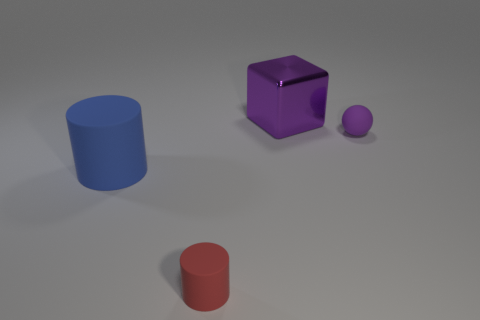Is there any other thing that has the same color as the matte sphere?
Provide a short and direct response. Yes. There is a tiny thing on the right side of the tiny object to the left of the small thing behind the big blue cylinder; what is its shape?
Your response must be concise. Sphere. Is the size of the purple thing that is behind the small purple sphere the same as the red rubber thing in front of the large blue rubber object?
Provide a succinct answer. No. What number of large blue cylinders are made of the same material as the large purple object?
Ensure brevity in your answer.  0. There is a cylinder right of the large matte cylinder in front of the purple sphere; how many spheres are behind it?
Your answer should be very brief. 1. Is the red rubber thing the same shape as the big blue thing?
Your answer should be very brief. Yes. Are there any large blue objects of the same shape as the small red thing?
Your answer should be compact. Yes. The other object that is the same size as the purple metallic thing is what shape?
Your answer should be very brief. Cylinder. What material is the big thing that is to the right of the rubber cylinder left of the tiny object in front of the large blue cylinder?
Ensure brevity in your answer.  Metal. Do the purple metal object and the purple ball have the same size?
Keep it short and to the point. No. 